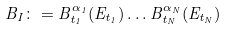<formula> <loc_0><loc_0><loc_500><loc_500>B _ { I } \colon = B ^ { \alpha _ { 1 } } _ { t _ { 1 } } ( E _ { t _ { 1 } } ) \dots B _ { t _ { N } } ^ { \alpha _ { N } } ( E _ { t _ { N } } )</formula> 